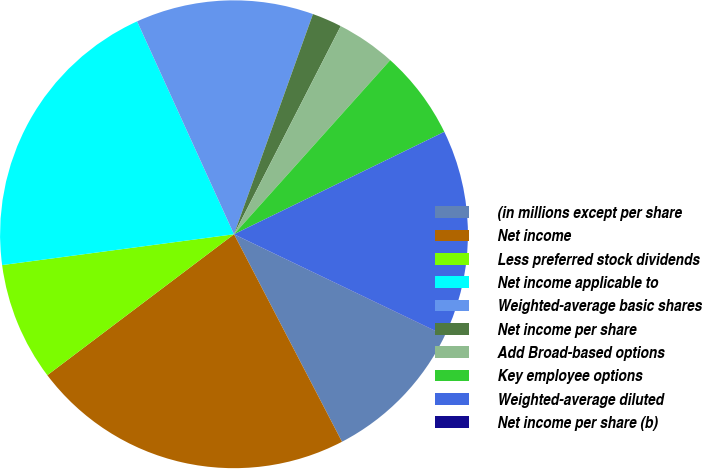Convert chart. <chart><loc_0><loc_0><loc_500><loc_500><pie_chart><fcel>(in millions except per share<fcel>Net income<fcel>Less preferred stock dividends<fcel>Net income applicable to<fcel>Weighted-average basic shares<fcel>Net income per share<fcel>Add Broad-based options<fcel>Key employee options<fcel>Weighted-average diluted<fcel>Net income per share (b)<nl><fcel>10.24%<fcel>22.35%<fcel>8.19%<fcel>20.31%<fcel>12.28%<fcel>2.06%<fcel>4.1%<fcel>6.15%<fcel>14.33%<fcel>0.01%<nl></chart> 